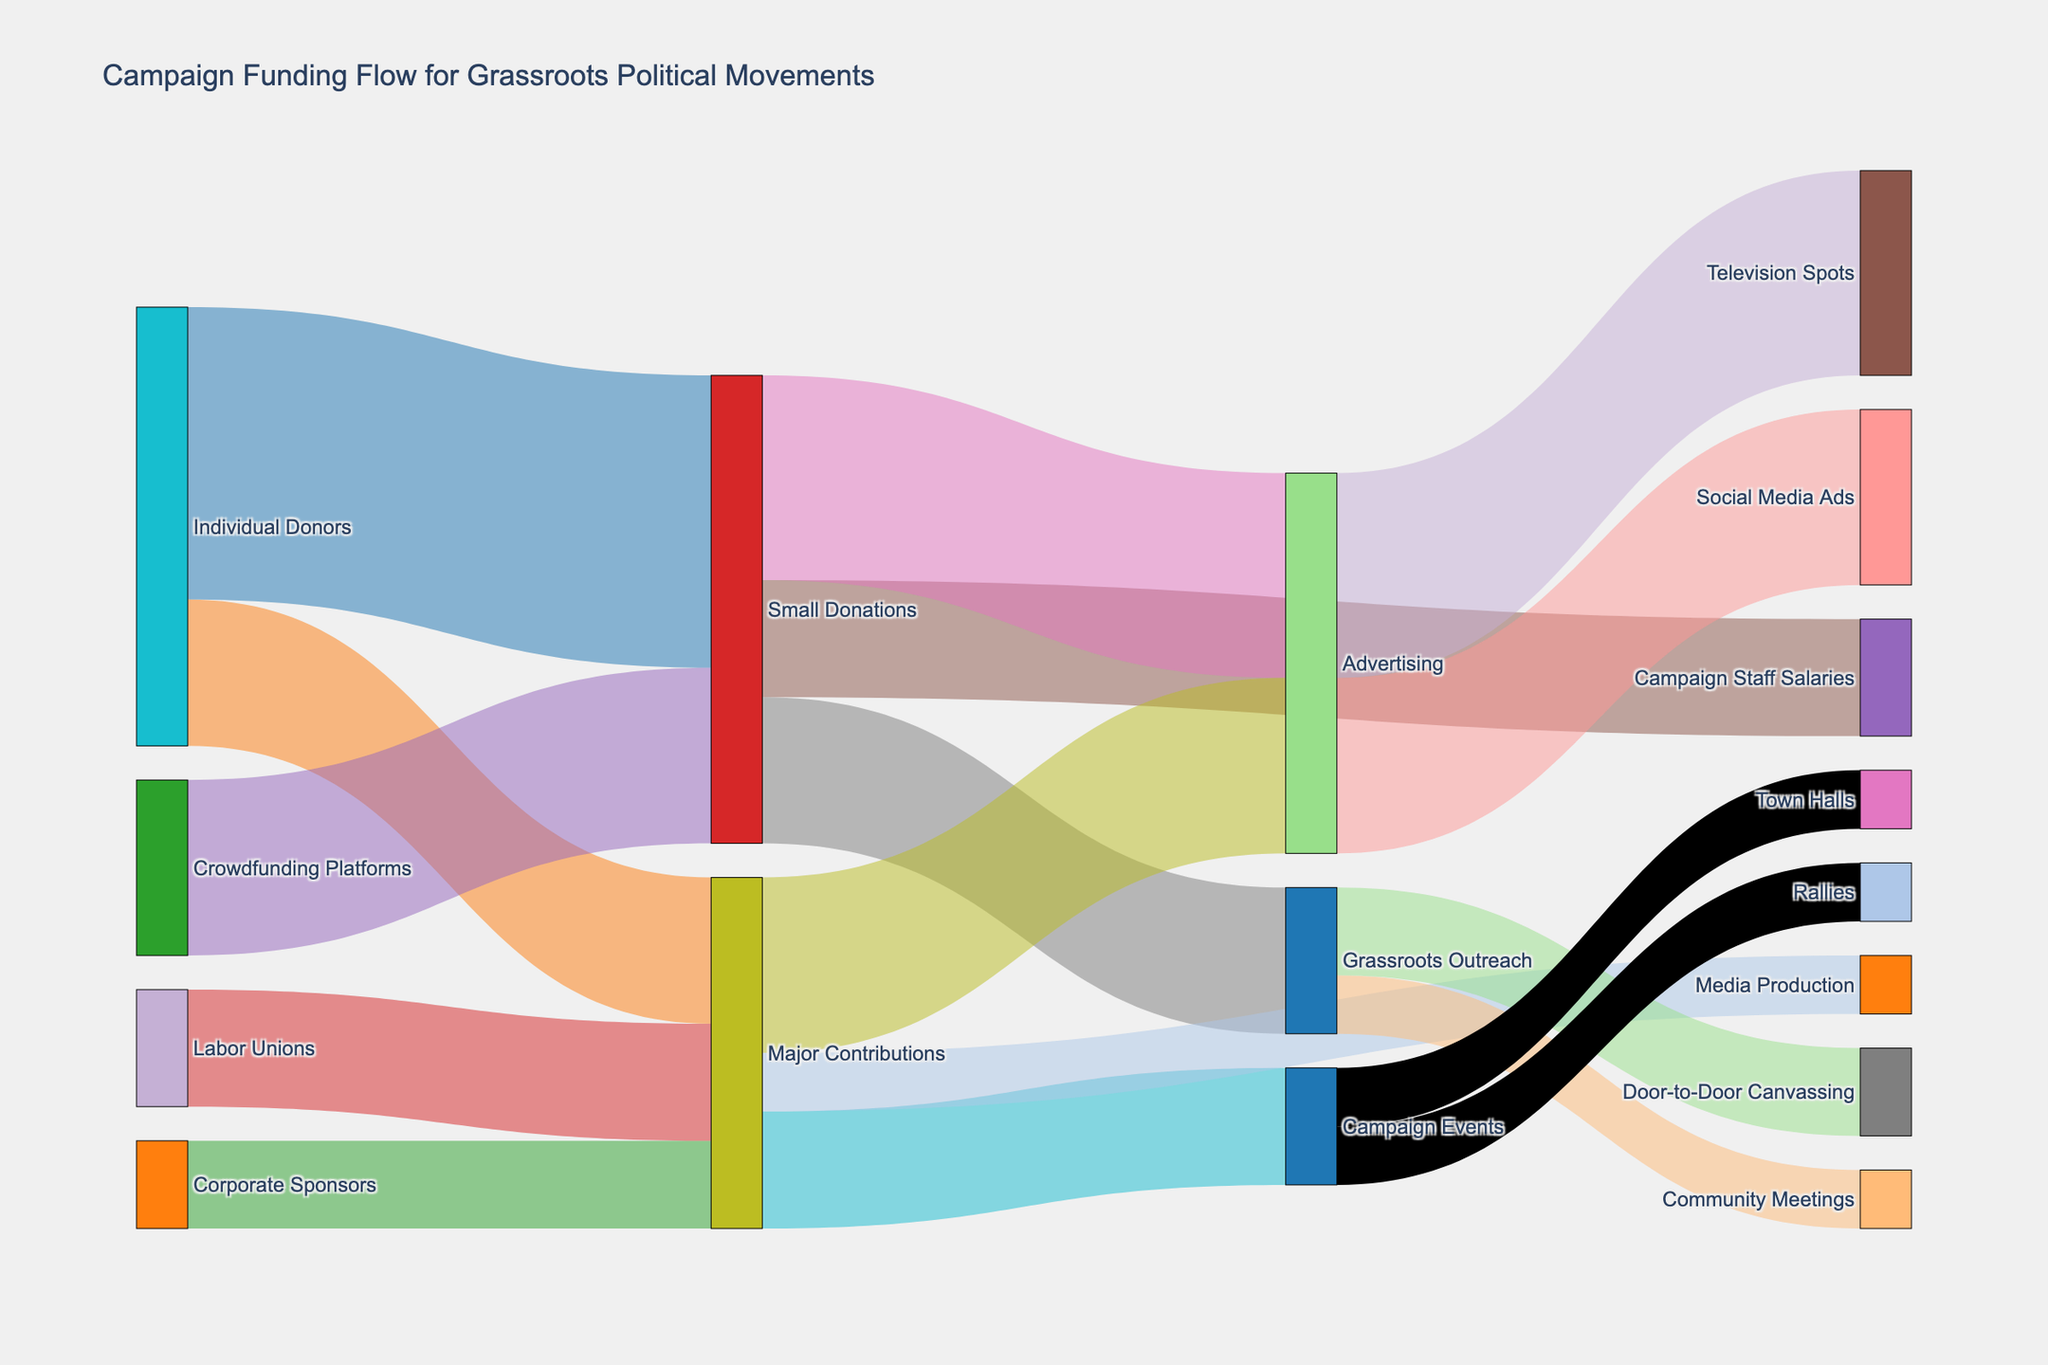What is the title of the figure? The title is usually located at the top center of the figure. In this case, it indicates the purpose of the graphical representation.
Answer: Campaign Funding Flow for Grassroots Political Movements How much funding is sourced from Individual Donors? To find this, look for the nodes connected directly from "Individual Donors". Add up the values of the direct flows from this source.
Answer: 750,000 Which source provides the least amount of funding? Compare the values of flows from all sources. The one with the smallest value is the least provider.
Answer: Corporate Sponsors Which allocation received the highest amount of Small Donations? Look for the targets directly connected to "Small Donations" and compare the values to find the highest one.
Answer: Advertising What is the combined total value of Major Contributions flowing into Advertising and Campaign Events? Identify the values of flows from "Major Contributions" to "Advertising" and "Campaign Events", add these values together.
Answer: 500,000 Which activity under Advertising receives the higher funding: Social Media Ads or Television Spots? Compare the flow values directed to "Social Media Ads" and "Television Spots".
Answer: Television Spots What percentage of Campaign Staff Salaries is funded by Small Donations? Find the value for Small Donations to Campaign Staff Salaries and divide it by the total Small Donations, then multiply by 100 to get the percentage. (200,000 / 1,050,000) * 100%.
Answer: 19.05% How much total funding is allocated to Grassroots Outreach activities? Identify the values of flows directed to activities under "Grassroots Outreach" like Community Meetings and Door-to-Door Canvassing, then sum these values.
Answer: 250,000 What is the difference in funding between Door-to-Door Canvassing and Community Meetings? Subtract the value of funding to Community Meetings from that to Door-to-Door Canvassing.
Answer: 50,000 What is the color of the node representing Labor Unions? Identify the color assigned to the "Labor Unions" node directly from the color palette used in the diagram.
Answer: Purple (assuming it corresponds to '#9467bd') 